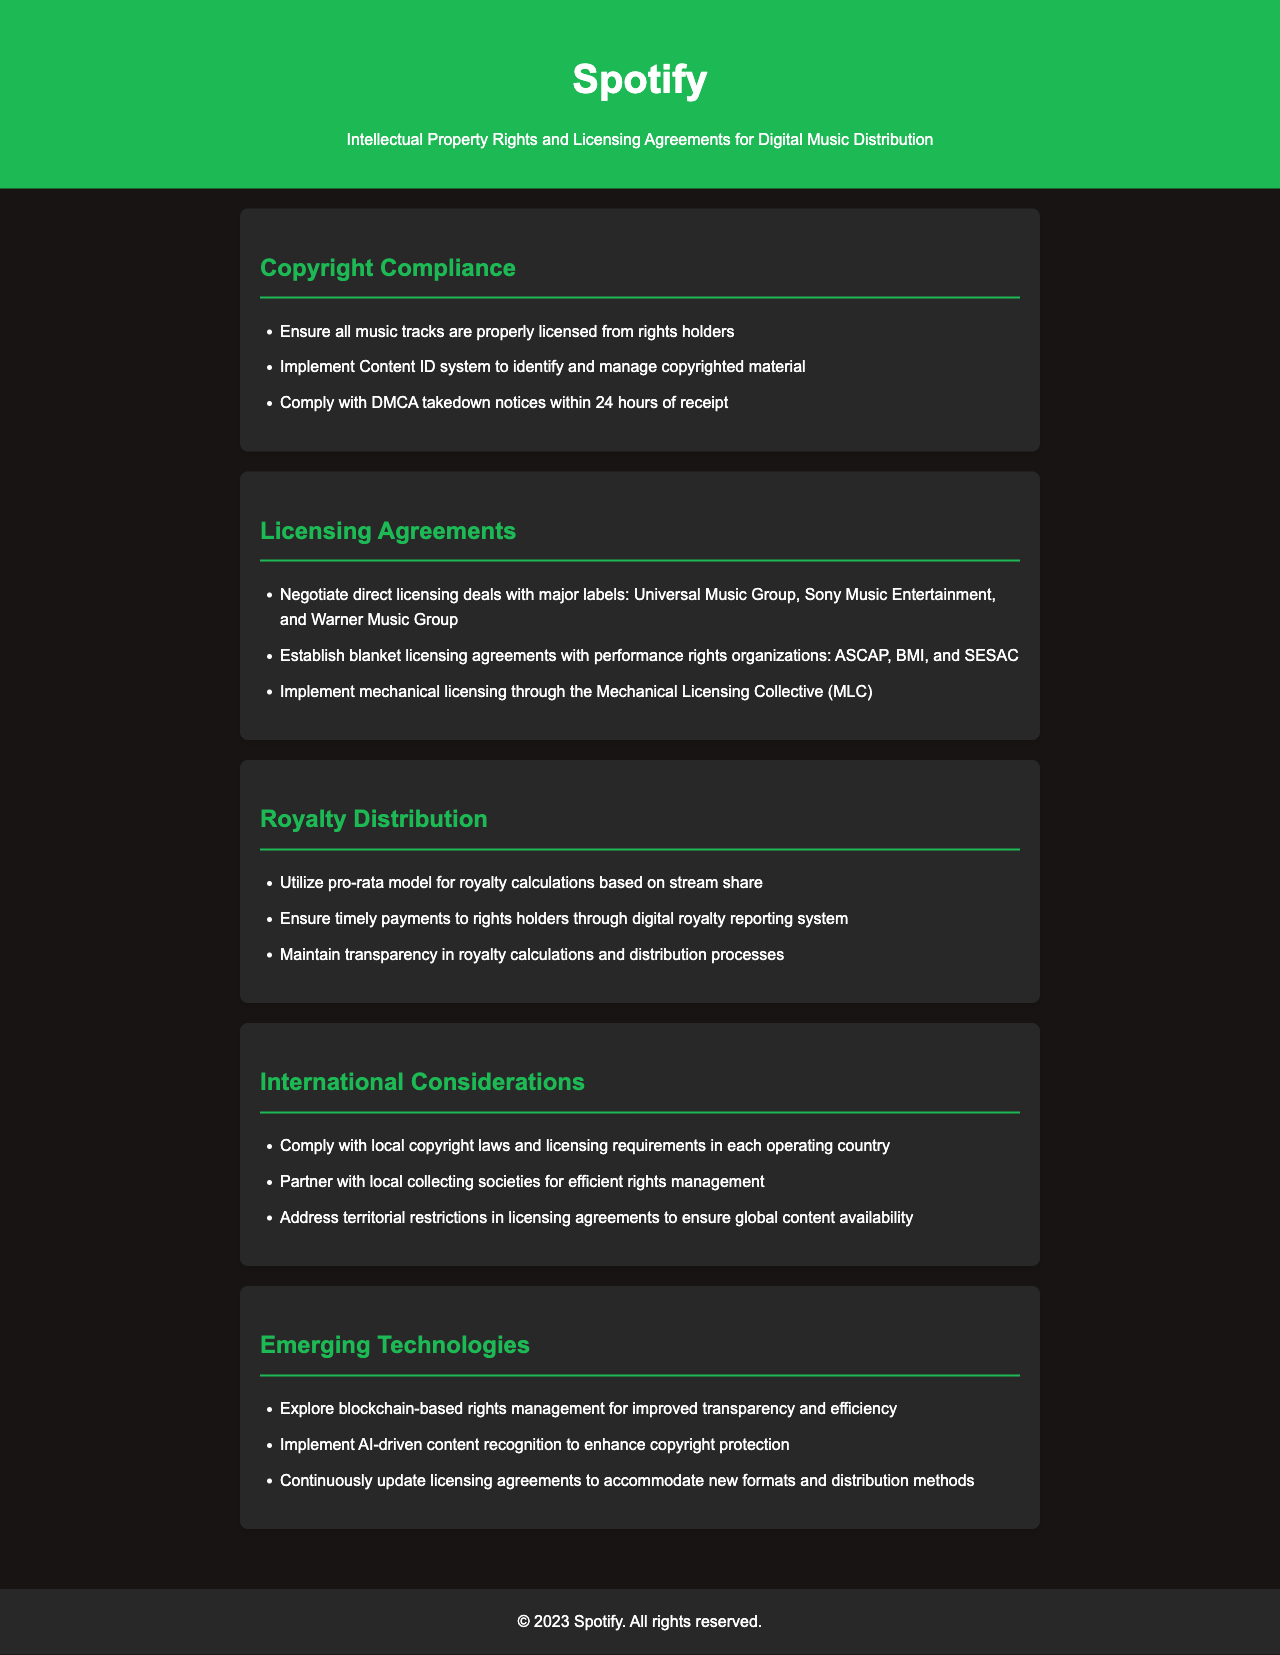What are the three major labels mentioned? The document lists Universal Music Group, Sony Music Entertainment, and Warner Music Group as the major labels.
Answer: Universal Music Group, Sony Music Entertainment, Warner Music Group What does DMCA stand for? The document implies the DMCA refers to the act requiring compliance with takedown notices.
Answer: Digital Millennium Copyright Act What is the pro-rata model used for? The pro-rata model is used for royalty calculations based on stream share in the document.
Answer: Royalty calculations How soon must takedown notices be complied with? The document states that takedown notices must be complied with within 24 hours.
Answer: 24 hours What organizations are mentioned for blanket licensing agreements? The document mentions ASCAP, BMI, and SESAC for blanket licensing agreements.
Answer: ASCAP, BMI, SESAC What emerging technology is suggested for rights management? The document suggests exploring blockchain-based rights management for improved transparency.
Answer: Blockchain What is the purpose of the Content ID system? The Content ID system is implemented to identify and manage copyrighted material.
Answer: Identify and manage copyrighted material What is the main focus of the "International Considerations" section? The main focus is on compliance with local copyright laws and licensing requirements in each country.
Answer: Compliance with local copyright laws What kind of model does the document utilize for royalty distribution? The document utilizes a pro-rata model for royalty calculations.
Answer: Pro-rata model 